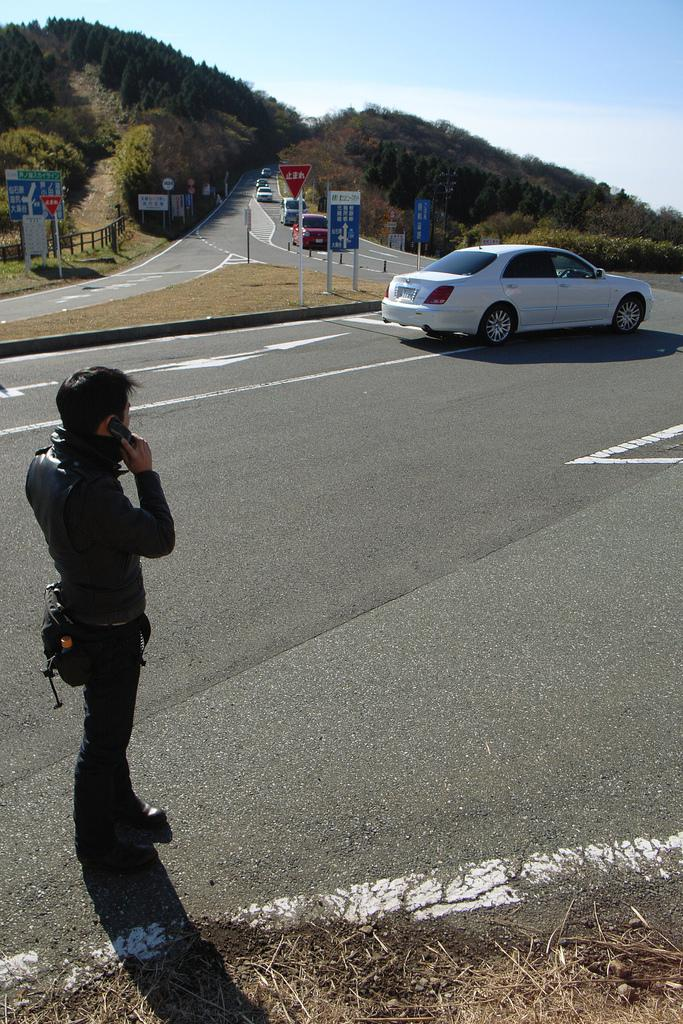Question: what season is it?
Choices:
A. Fall.
B. Winter.
C. Summer.
D. Spring.
Answer with the letter. Answer: C Question: why are white lines on the road?
Choices:
A. To designate the lanes.
B. To keep people in there lane.
C. To control traffic.
D. To avoid accidents.
Answer with the letter. Answer: A Question: how many cars are there?
Choices:
A. 8.
B. 9.
C. 7.
D. 6.
Answer with the letter. Answer: D Question: how is the weather?
Choices:
A. It's chilly.
B. It's sunny.
C. It's windy.
D. It's cold.
Answer with the letter. Answer: B Question: who is making a phone call?
Choices:
A. My husband.
B. That young girl.
C. The man in black.
D. The cashier.
Answer with the letter. Answer: C Question: where is the white car?
Choices:
A. At the end of the street.
B. At the house.
C. At the intersection.
D. At the park.
Answer with the letter. Answer: C Question: who is wearing a black jacket?
Choices:
A. Man.
B. Woman.
C. Boy.
D. Girl.
Answer with the letter. Answer: A Question: what is paused waiting to turn?
Choices:
A. White car.
B. Blue truck.
C. Black motorcycle.
D. Red car.
Answer with the letter. Answer: A Question: what drives up a hill?
Choices:
A. Line of trucks.
B. Motorcycles.
C. Mopeds.
D. Line of cars.
Answer with the letter. Answer: D Question: what color signs provide directions?
Choices:
A. Yellow.
B. White.
C. Green.
D. Blue.
Answer with the letter. Answer: D Question: what do the red signs with white letters look like?
Choices:
A. Warning signs.
B. Upside down pyramids.
C. Peppermint colored signs.
D. Upside down triangles.
Answer with the letter. Answer: D Question: what in the photo is dead and brown?
Choices:
A. The grass.
B. The leaves.
C. The bushes.
D. The flowers.
Answer with the letter. Answer: A Question: where is the white sedan stopped?
Choices:
A. At the stop sign.
B. At the intersection.
C. In front of the store.
D. In front of the toll gate.
Answer with the letter. Answer: B Question: who is dressed in all black?
Choices:
A. The woman.
B. The man.
C. The young girl.
D. The young boy.
Answer with the letter. Answer: B 